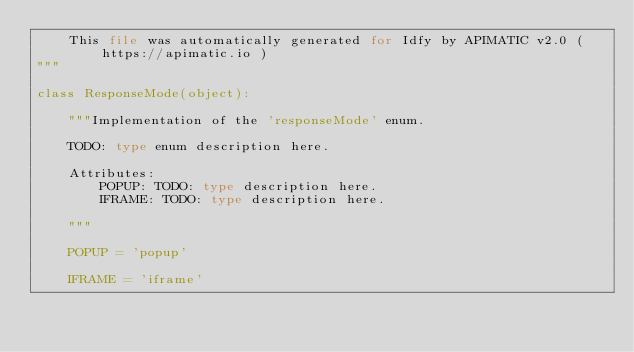Convert code to text. <code><loc_0><loc_0><loc_500><loc_500><_Python_>    This file was automatically generated for Idfy by APIMATIC v2.0 ( https://apimatic.io )
"""

class ResponseMode(object):

    """Implementation of the 'responseMode' enum.

    TODO: type enum description here.

    Attributes:
        POPUP: TODO: type description here.
        IFRAME: TODO: type description here.

    """

    POPUP = 'popup'

    IFRAME = 'iframe'

</code> 